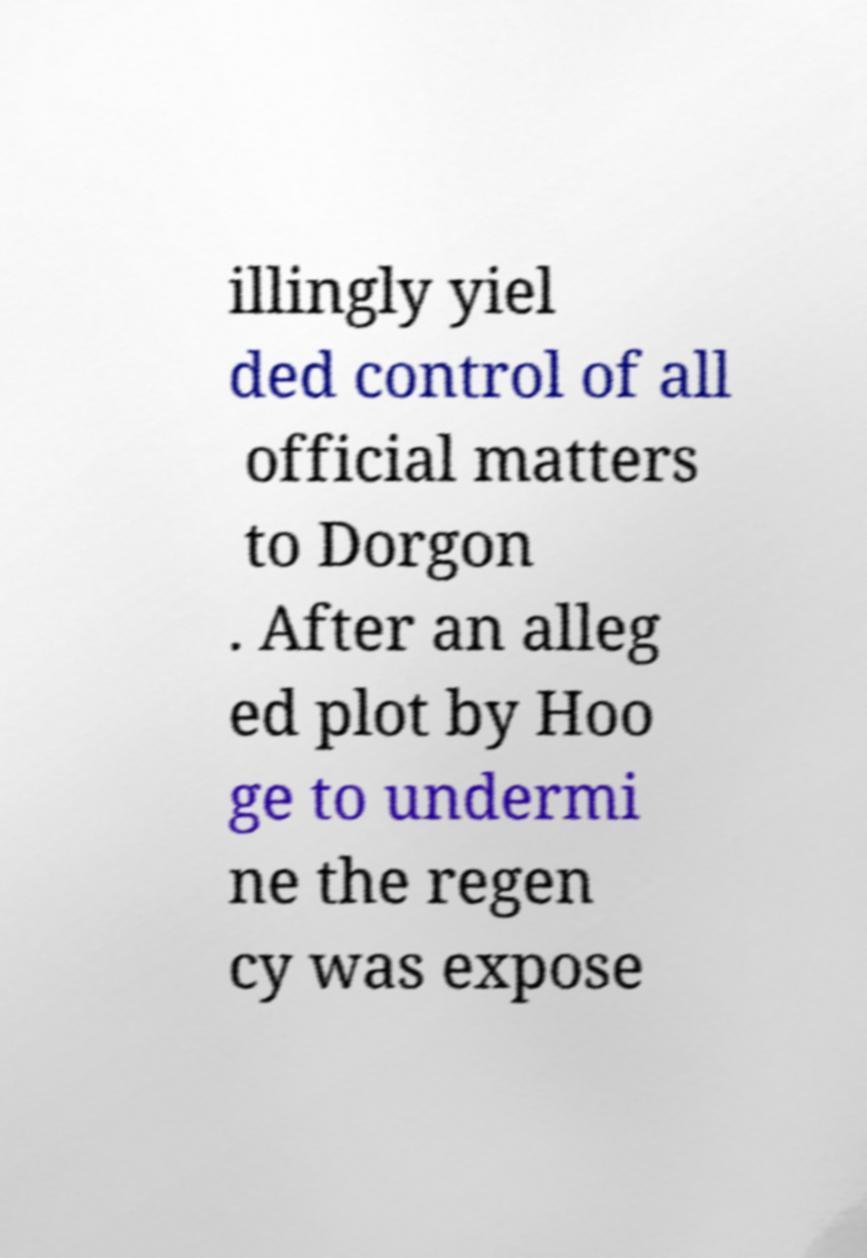What messages or text are displayed in this image? I need them in a readable, typed format. illingly yiel ded control of all official matters to Dorgon . After an alleg ed plot by Hoo ge to undermi ne the regen cy was expose 